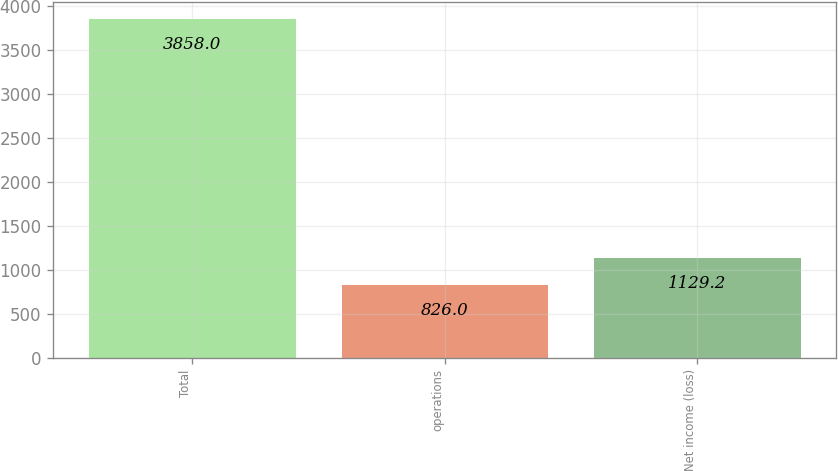Convert chart to OTSL. <chart><loc_0><loc_0><loc_500><loc_500><bar_chart><fcel>Total<fcel>operations<fcel>Net income (loss)<nl><fcel>3858<fcel>826<fcel>1129.2<nl></chart> 